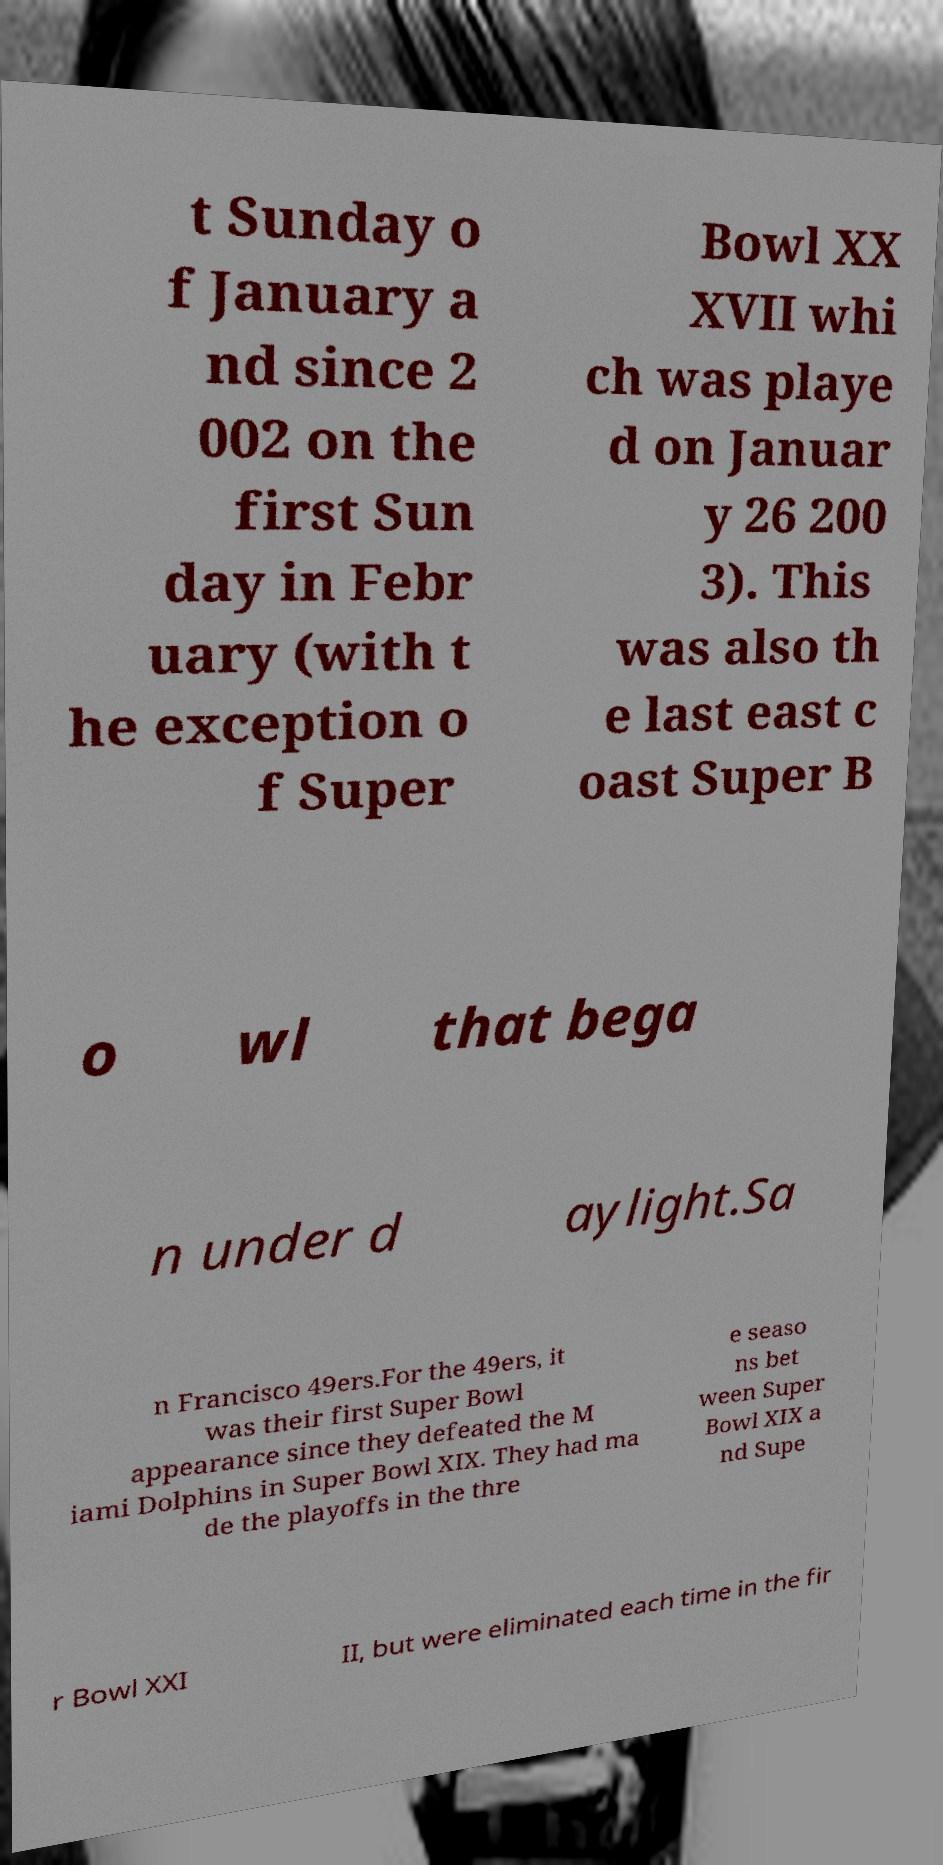Can you read and provide the text displayed in the image?This photo seems to have some interesting text. Can you extract and type it out for me? t Sunday o f January a nd since 2 002 on the first Sun day in Febr uary (with t he exception o f Super Bowl XX XVII whi ch was playe d on Januar y 26 200 3). This was also th e last east c oast Super B o wl that bega n under d aylight.Sa n Francisco 49ers.For the 49ers, it was their first Super Bowl appearance since they defeated the M iami Dolphins in Super Bowl XIX. They had ma de the playoffs in the thre e seaso ns bet ween Super Bowl XIX a nd Supe r Bowl XXI II, but were eliminated each time in the fir 